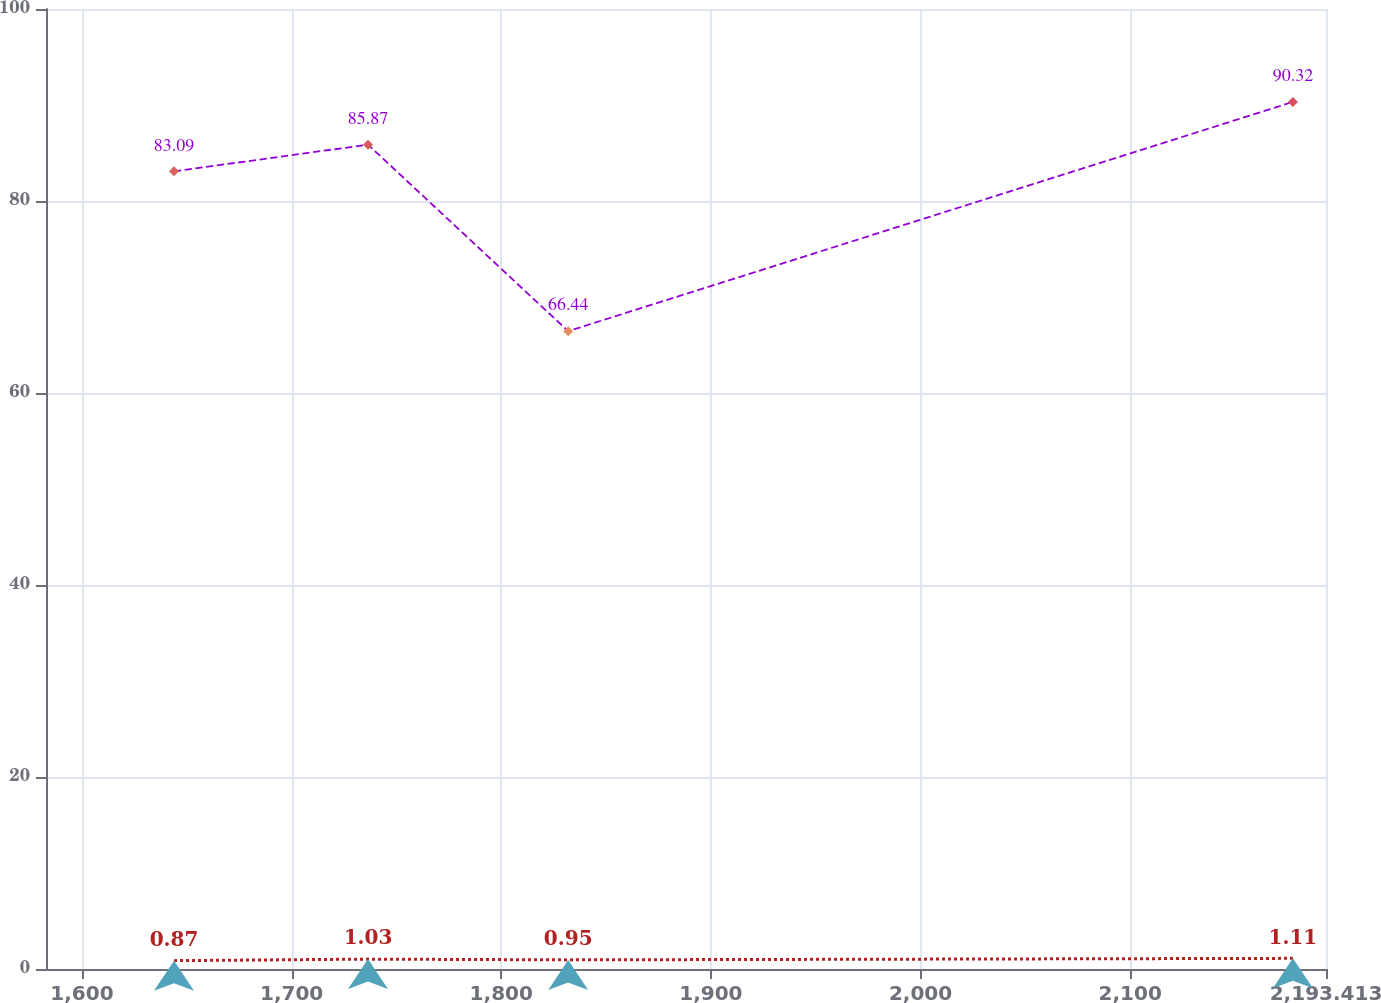<chart> <loc_0><loc_0><loc_500><loc_500><line_chart><ecel><fcel>Postretirement<fcel>Pension<nl><fcel>1643.9<fcel>83.09<fcel>0.87<nl><fcel>1736.44<fcel>85.87<fcel>1.03<nl><fcel>1831.93<fcel>66.44<fcel>0.95<nl><fcel>2177.62<fcel>90.32<fcel>1.11<nl><fcel>2254.47<fcel>69.25<fcel>1.66<nl></chart> 